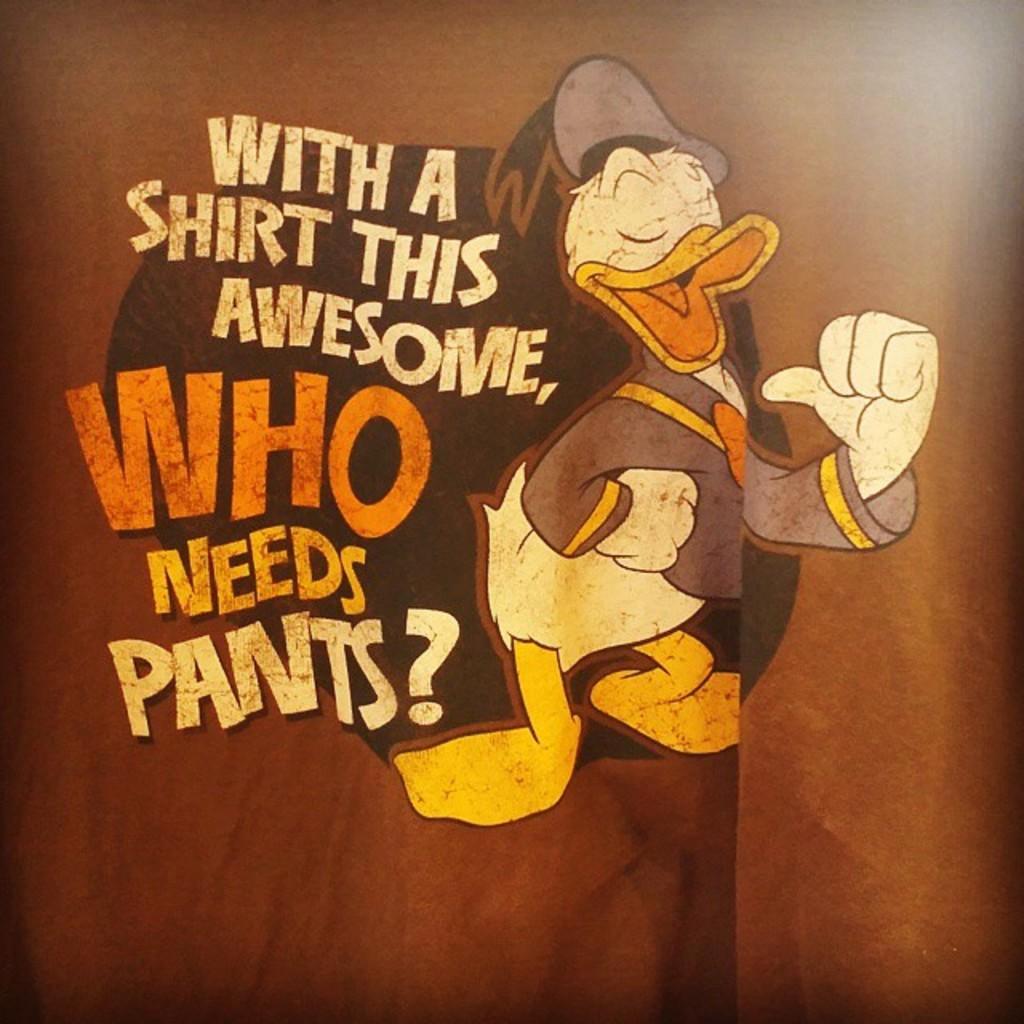Can you describe this image briefly? In this image we can see a Donald duck and some edited text on the brown color background. 